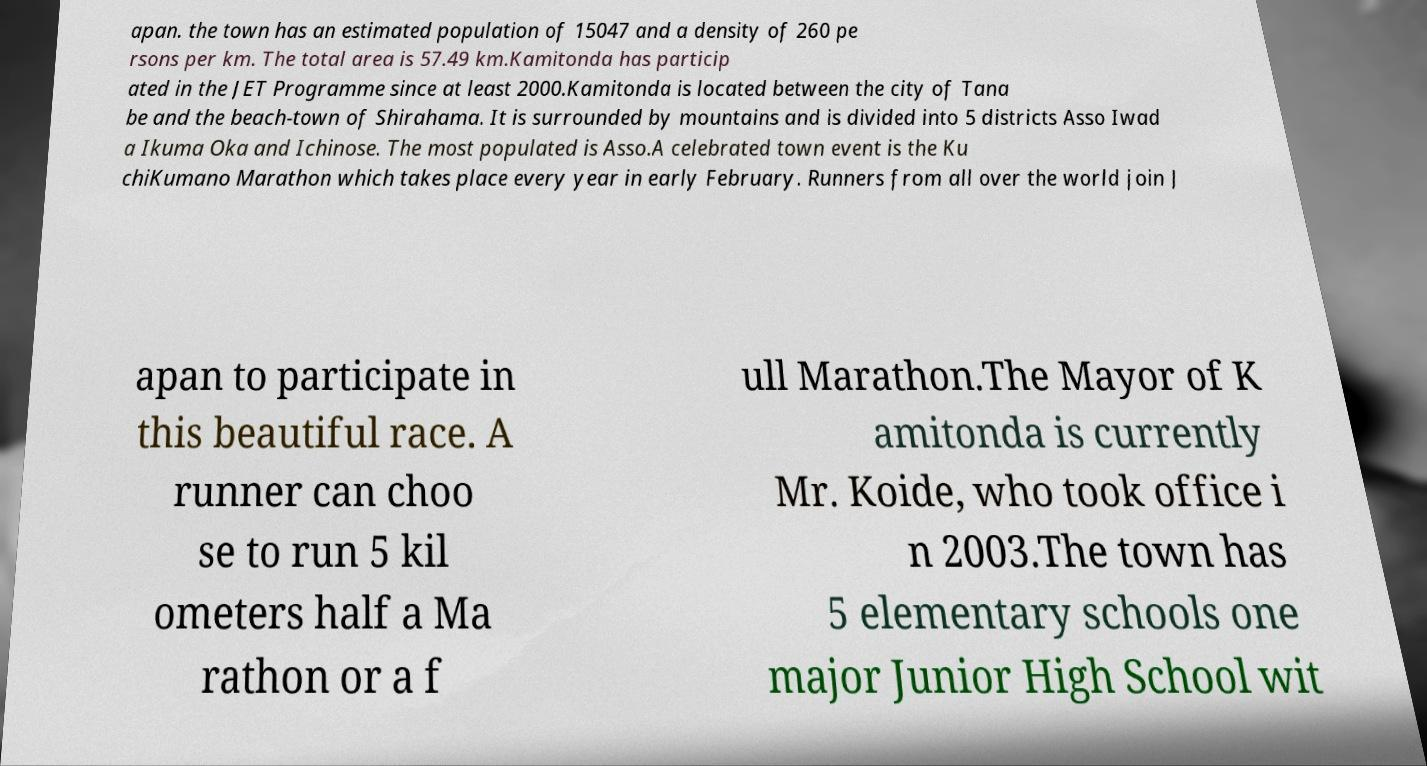Please identify and transcribe the text found in this image. apan. the town has an estimated population of 15047 and a density of 260 pe rsons per km. The total area is 57.49 km.Kamitonda has particip ated in the JET Programme since at least 2000.Kamitonda is located between the city of Tana be and the beach-town of Shirahama. It is surrounded by mountains and is divided into 5 districts Asso Iwad a Ikuma Oka and Ichinose. The most populated is Asso.A celebrated town event is the Ku chiKumano Marathon which takes place every year in early February. Runners from all over the world join J apan to participate in this beautiful race. A runner can choo se to run 5 kil ometers half a Ma rathon or a f ull Marathon.The Mayor of K amitonda is currently Mr. Koide, who took office i n 2003.The town has 5 elementary schools one major Junior High School wit 